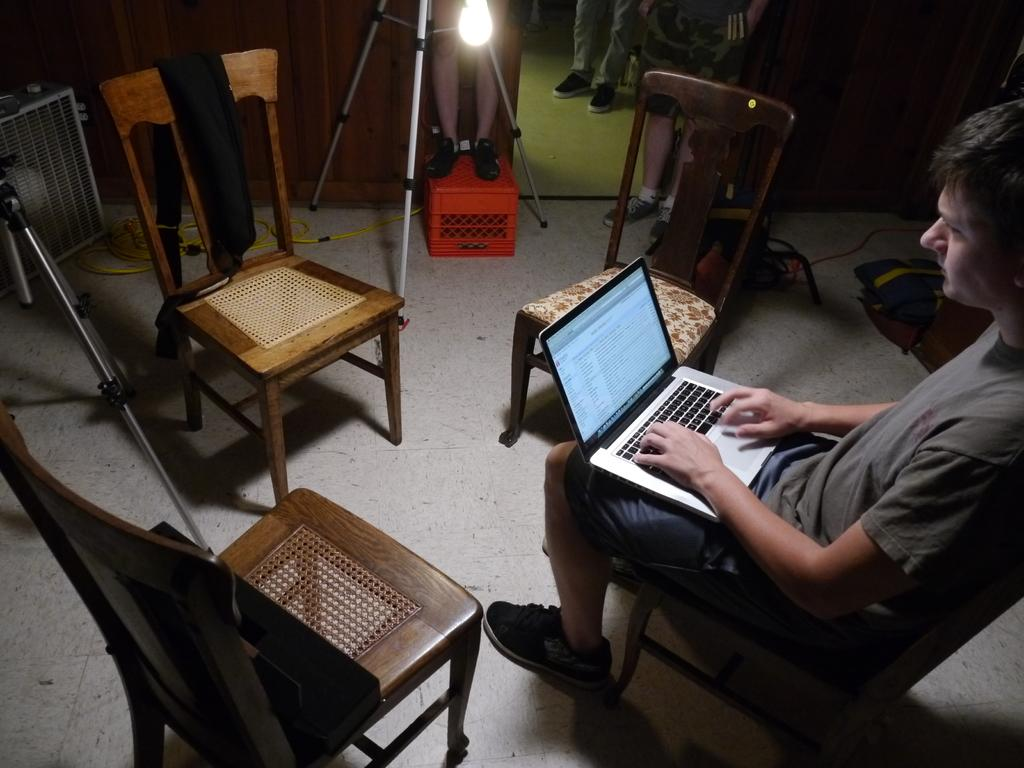What is the man in the image doing? The man is sitting on a chair in the image. How many chairs are visible in the image? There are chairs on the floor in the image. What can be seen providing illumination in the image? There is a light in the image. What is visible beneath the man and chairs in the image? The floor is visible in the image. What type of bun is the man wearing on his head in the image? There is no bun present on the man's head in the image. What kind of glove is the man wearing while sitting on the chair? The man is not wearing any gloves in the image. 